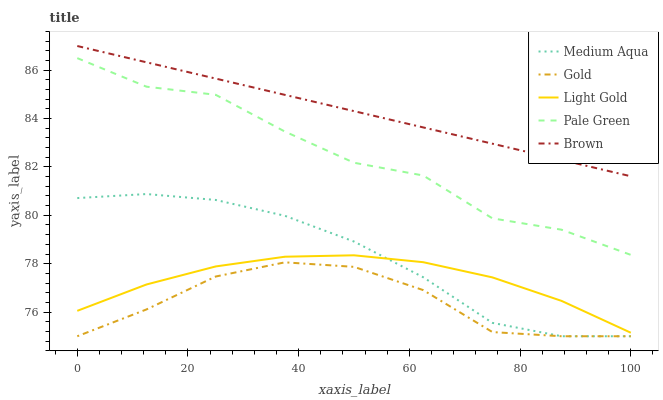Does Pale Green have the minimum area under the curve?
Answer yes or no. No. Does Pale Green have the maximum area under the curve?
Answer yes or no. No. Is Medium Aqua the smoothest?
Answer yes or no. No. Is Medium Aqua the roughest?
Answer yes or no. No. Does Pale Green have the lowest value?
Answer yes or no. No. Does Pale Green have the highest value?
Answer yes or no. No. Is Light Gold less than Brown?
Answer yes or no. Yes. Is Brown greater than Gold?
Answer yes or no. Yes. Does Light Gold intersect Brown?
Answer yes or no. No. 